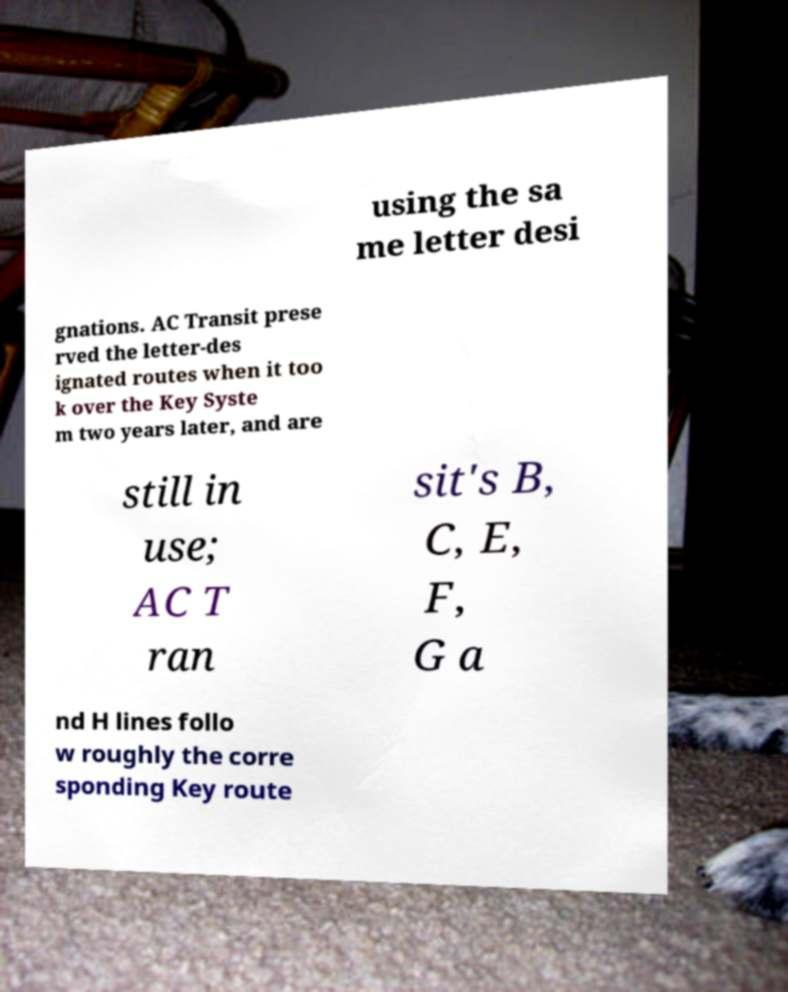I need the written content from this picture converted into text. Can you do that? using the sa me letter desi gnations. AC Transit prese rved the letter-des ignated routes when it too k over the Key Syste m two years later, and are still in use; AC T ran sit's B, C, E, F, G a nd H lines follo w roughly the corre sponding Key route 